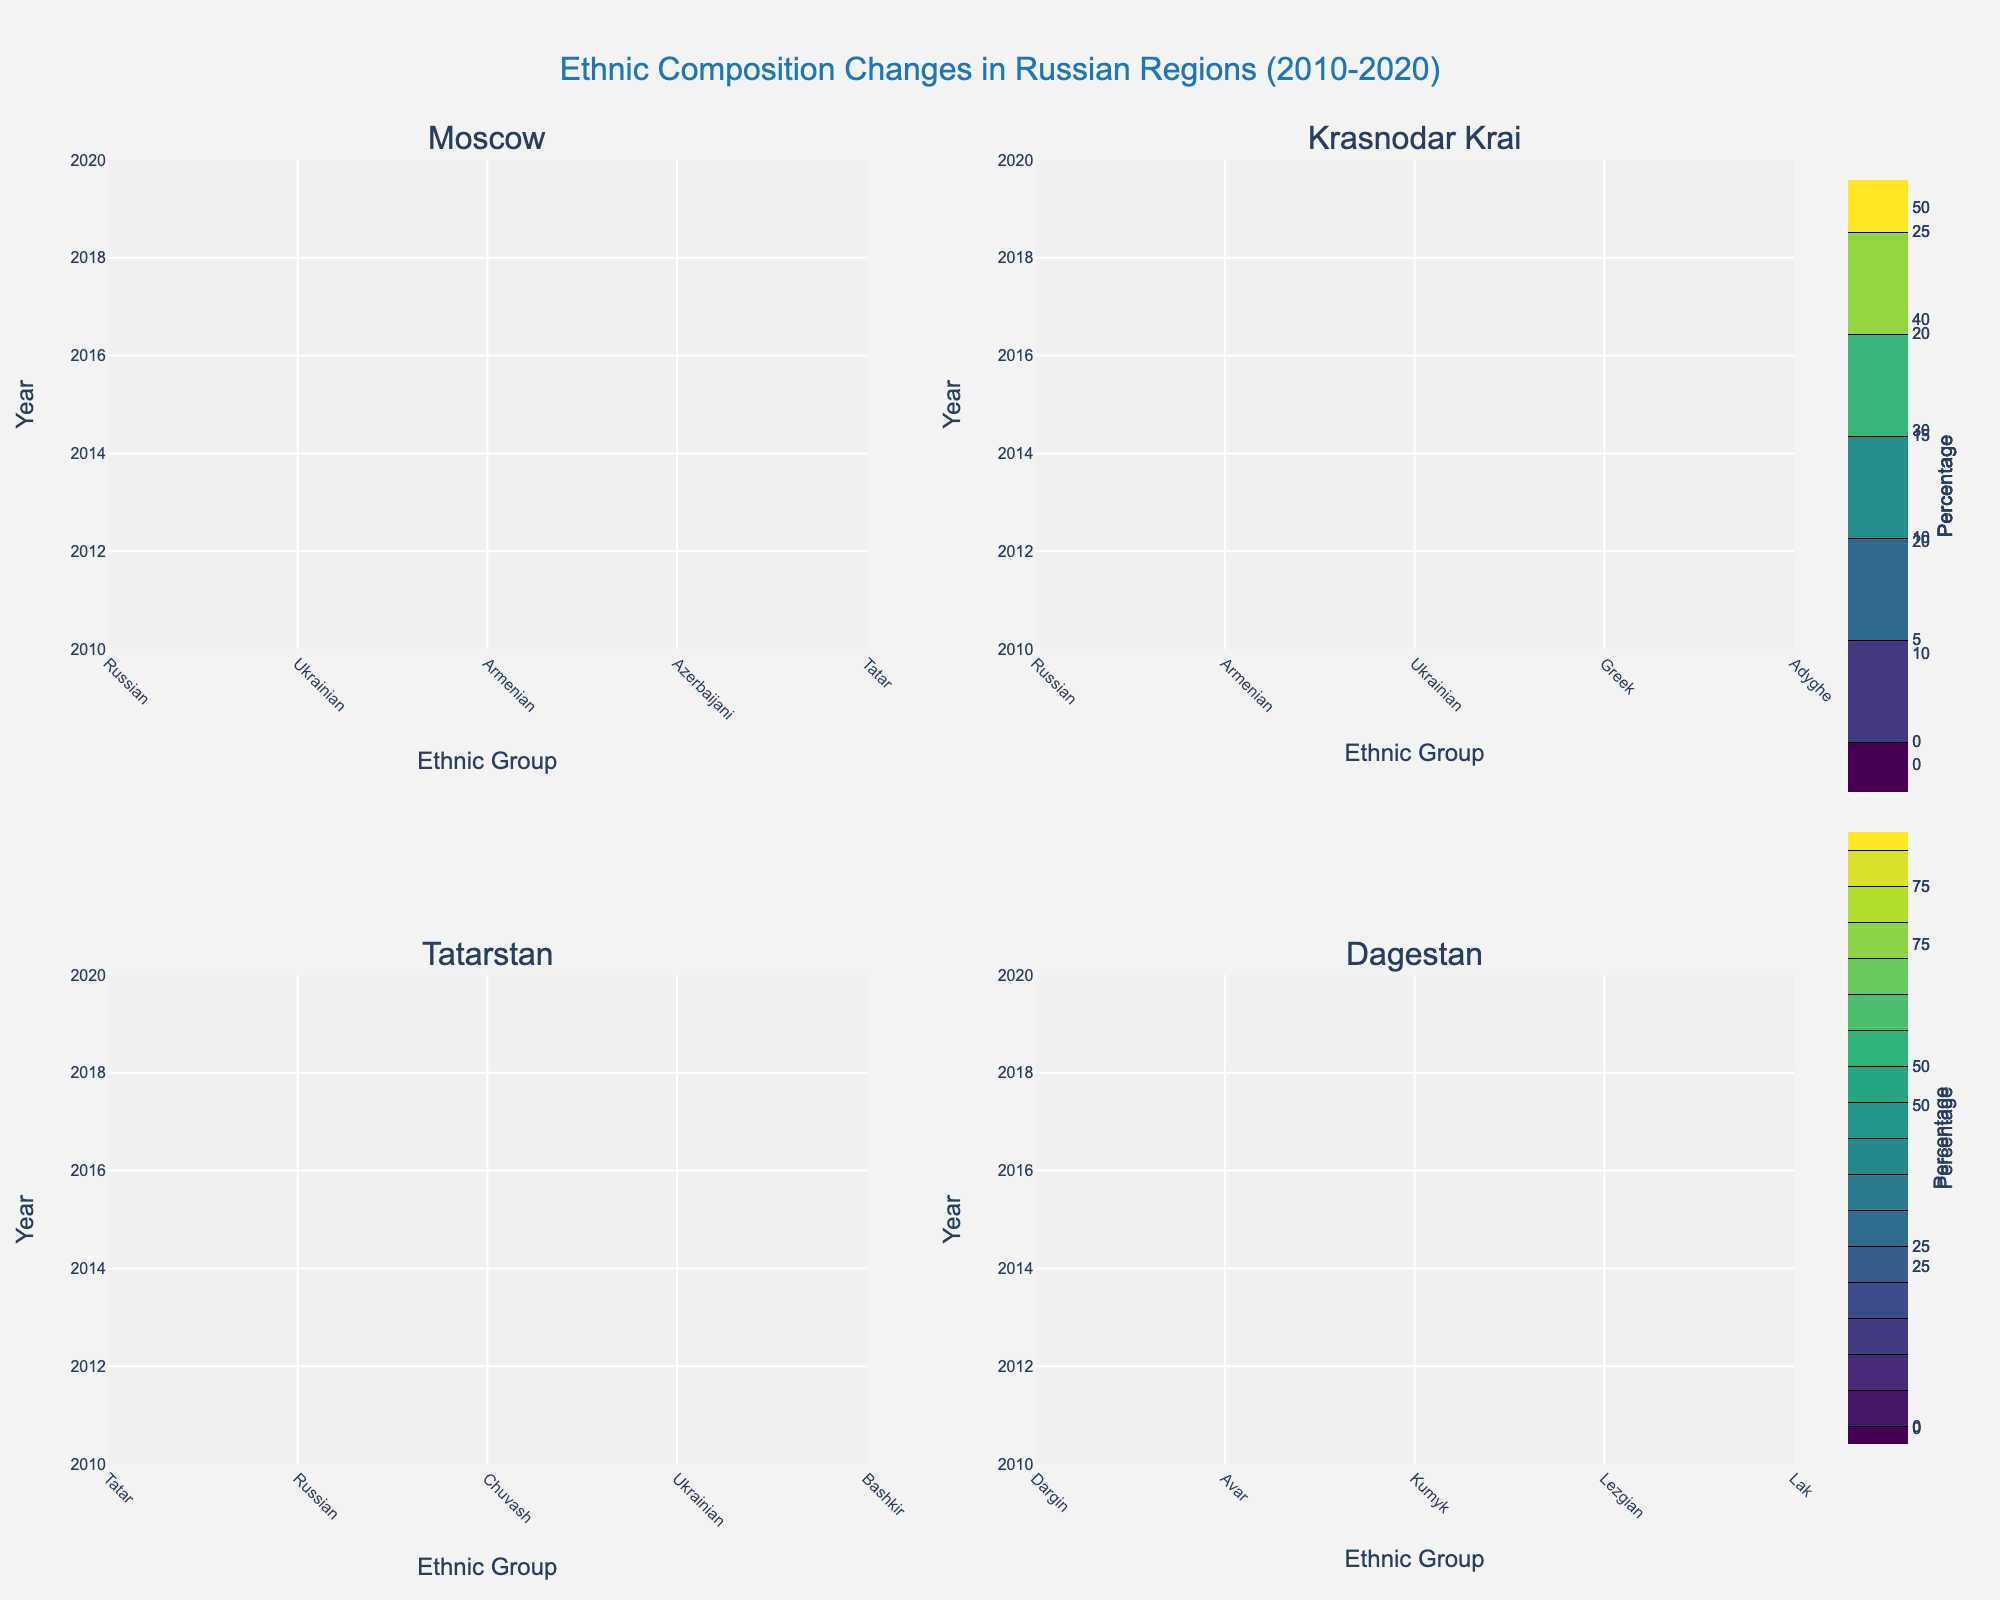What is the title of the figure? The title is positioned at the top center of the plot. It reads "Ethnic Composition Changes in Russian Regions (2010-2020)".
Answer: Ethnic Composition Changes in Russian Regions (2010-2020) How many regions are examined in the figure? The figure consists of four subplots, each corresponding to a different region.
Answer: Four Which ethnic group in Moscow had the highest percentage in both 2010 and 2020? By observing the contours in the subplot for Moscow, the Russian ethnic group has the highest percentage in both years.
Answer: Russian How did the percentage of the Ukrainian ethnic group change in Moscow from 2010 to 2020? First, locate the contour for the Ukrainian ethnic group in Moscow for both years. In 2010, it was 1.8%, and in 2020, it was 1.5%. Thus, it decreased by 0.3%.
Answer: Decreased by 0.3% In which region did the Armenian ethnic group see an increase in percentage over the decade? Observe all the subplots for changes in the percentage of the Armenian ethnic group from 2010 to 2020. In Krasnodar Krai (rural), the percentage increased from 5.2% to 5.8%.
Answer: Krasnodar Krai What was the change in the percentage of the Russian ethnic group in Tatarstan (urban) from 2010 to 2020? In the Tatarstan subplot, the contour for the Russian ethnic group shows a change from 39.7% in 2010 to 38.2% in 2020. The percentage decreased by 1.5%.
Answer: Decreased by 1.5% Which region shows the most diverse ethnic composition based on the width of the contour lines? Dagestan's subplot has the widest spread of contour lines, indicating a more diverse ethnic composition compared to the other regions.
Answer: Dagestan Which ethnic group had the most significant percentage decline in Krasnodar Krai (rural) from 2010 to 2020? In the Krasnodar Krai subplot, observe changes for each ethnic group. The Greek ethnic group percentage decreased from 1.8% in 2010 to 1.6% in 2020. This is a decline of 0.2%, which is the most significant decline visible.
Answer: Greek Is there any ethnic group that remained relatively stable (with less than 0.2% change) in Dagestan (rural) over the decade? In the Dagestan subplot, compare the percentage changes for all ethnic groups. The Lak ethnic group remained relatively stable, changing only from 5.3% to 5.1%, a change of 0.2%.
Answer: Lak 